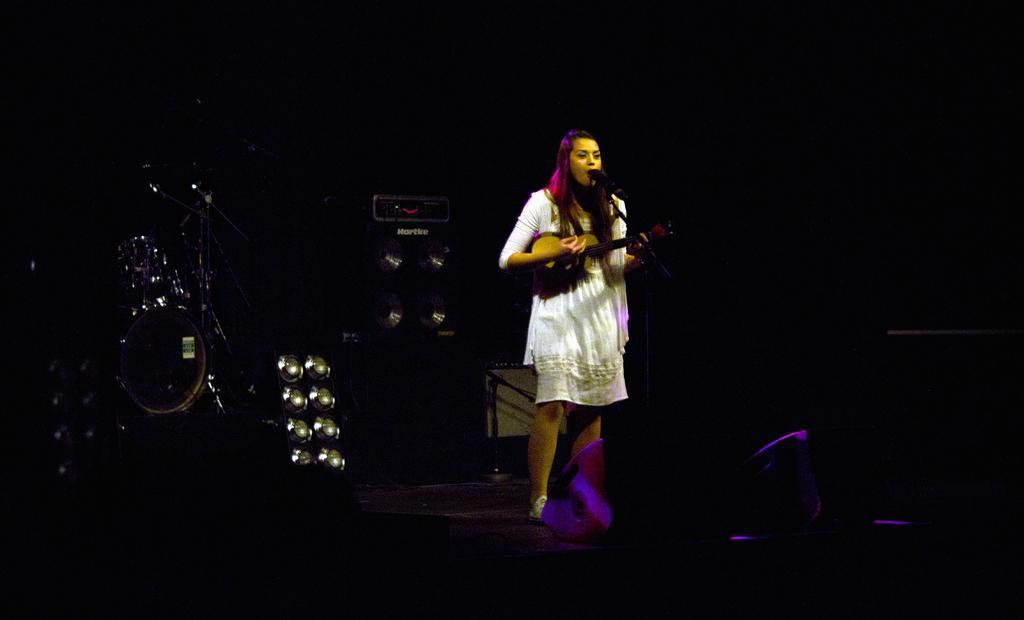How would you summarize this image in a sentence or two? in this image i can see a person playing guitar and singing. she is wearing a white dress. behind her there are speakers. 